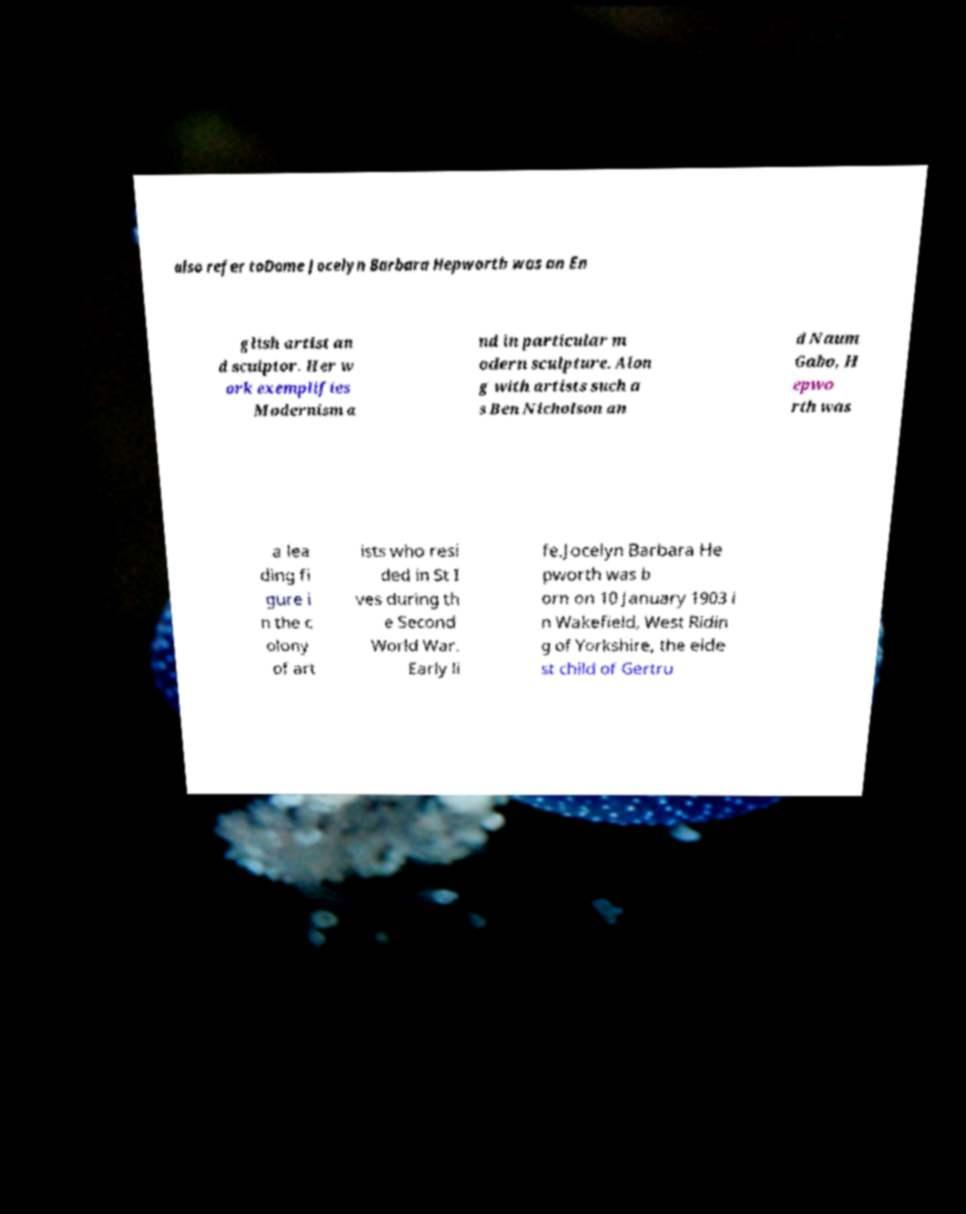I need the written content from this picture converted into text. Can you do that? also refer toDame Jocelyn Barbara Hepworth was an En glish artist an d sculptor. Her w ork exemplifies Modernism a nd in particular m odern sculpture. Alon g with artists such a s Ben Nicholson an d Naum Gabo, H epwo rth was a lea ding fi gure i n the c olony of art ists who resi ded in St I ves during th e Second World War. Early li fe.Jocelyn Barbara He pworth was b orn on 10 January 1903 i n Wakefield, West Ridin g of Yorkshire, the elde st child of Gertru 